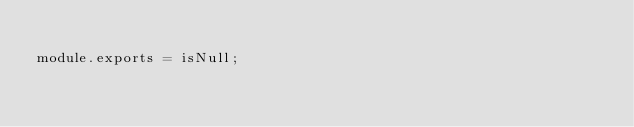<code> <loc_0><loc_0><loc_500><loc_500><_JavaScript_>
module.exports = isNull;</code> 